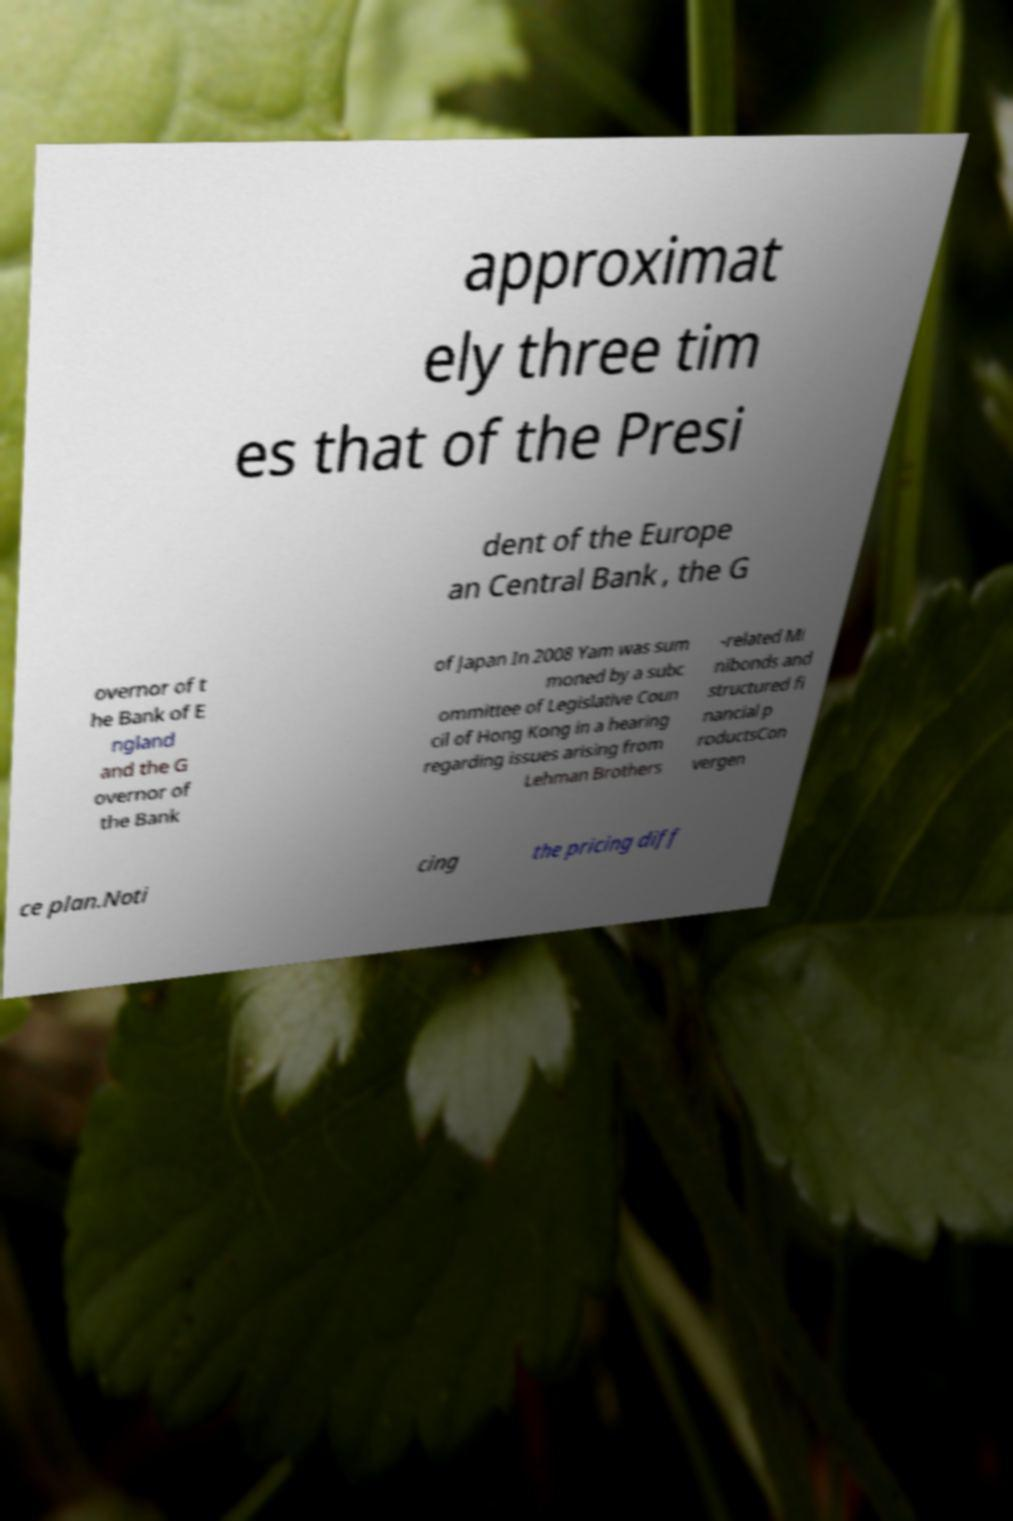Please identify and transcribe the text found in this image. approximat ely three tim es that of the Presi dent of the Europe an Central Bank , the G overnor of t he Bank of E ngland and the G overnor of the Bank of Japan In 2008 Yam was sum moned by a subc ommittee of Legislative Coun cil of Hong Kong in a hearing regarding issues arising from Lehman Brothers -related Mi nibonds and structured fi nancial p roductsCon vergen ce plan.Noti cing the pricing diff 